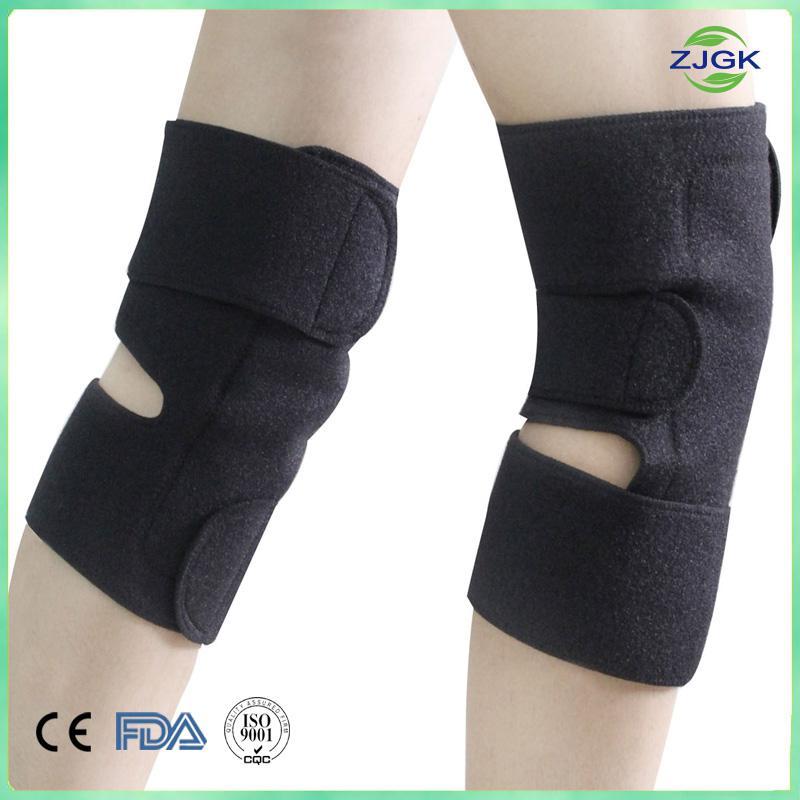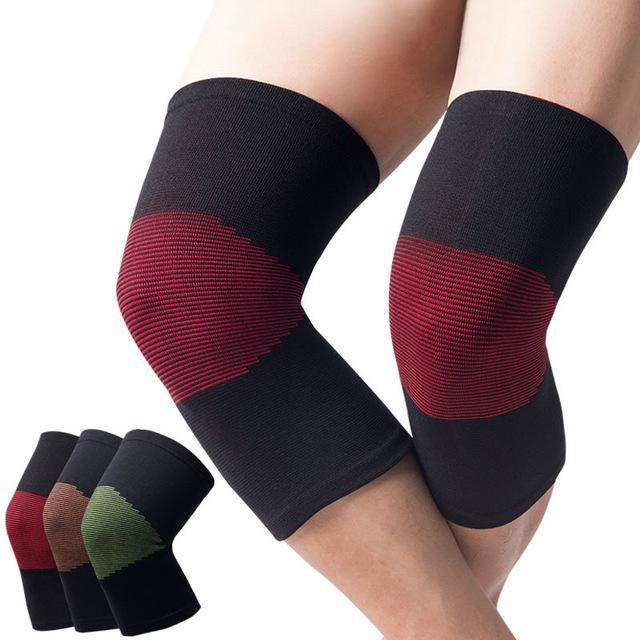The first image is the image on the left, the second image is the image on the right. Given the left and right images, does the statement "The left and right image each have at least on all black knee pads minus the labeling." hold true? Answer yes or no. No. The first image is the image on the left, the second image is the image on the right. Assess this claim about the two images: "Each image includes at least one human leg with exposed skin, and each human leg wears a knee wrap.". Correct or not? Answer yes or no. Yes. 